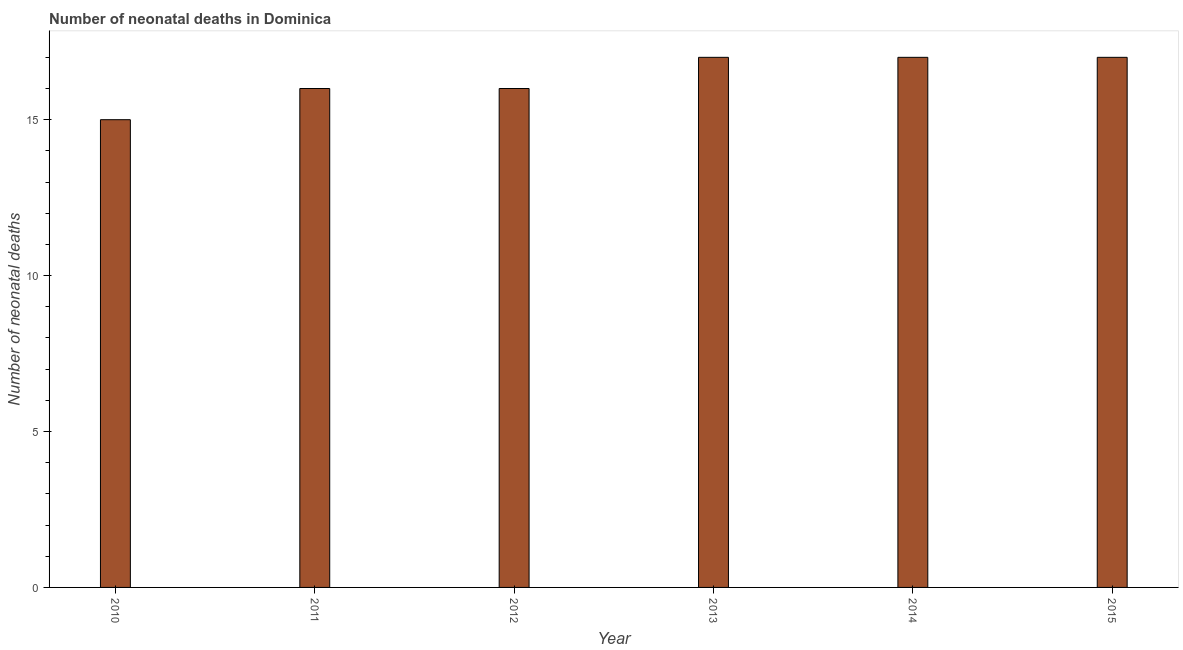Does the graph contain any zero values?
Provide a short and direct response. No. Does the graph contain grids?
Your response must be concise. No. What is the title of the graph?
Your answer should be compact. Number of neonatal deaths in Dominica. What is the label or title of the X-axis?
Your answer should be compact. Year. What is the label or title of the Y-axis?
Your answer should be compact. Number of neonatal deaths. What is the number of neonatal deaths in 2014?
Provide a succinct answer. 17. Across all years, what is the maximum number of neonatal deaths?
Your answer should be compact. 17. Across all years, what is the minimum number of neonatal deaths?
Ensure brevity in your answer.  15. In which year was the number of neonatal deaths maximum?
Your answer should be very brief. 2013. In which year was the number of neonatal deaths minimum?
Offer a very short reply. 2010. What is the difference between the number of neonatal deaths in 2014 and 2015?
Give a very brief answer. 0. What is the average number of neonatal deaths per year?
Your response must be concise. 16. In how many years, is the number of neonatal deaths greater than 2 ?
Your response must be concise. 6. Do a majority of the years between 2015 and 2013 (inclusive) have number of neonatal deaths greater than 13 ?
Your answer should be very brief. Yes. What is the ratio of the number of neonatal deaths in 2011 to that in 2013?
Keep it short and to the point. 0.94. What is the difference between the highest and the second highest number of neonatal deaths?
Your answer should be very brief. 0. Is the sum of the number of neonatal deaths in 2010 and 2011 greater than the maximum number of neonatal deaths across all years?
Your answer should be very brief. Yes. How many years are there in the graph?
Offer a very short reply. 6. Are the values on the major ticks of Y-axis written in scientific E-notation?
Your response must be concise. No. What is the Number of neonatal deaths in 2010?
Keep it short and to the point. 15. What is the Number of neonatal deaths of 2011?
Your response must be concise. 16. What is the Number of neonatal deaths of 2013?
Offer a very short reply. 17. What is the Number of neonatal deaths of 2014?
Offer a very short reply. 17. What is the difference between the Number of neonatal deaths in 2010 and 2011?
Offer a terse response. -1. What is the difference between the Number of neonatal deaths in 2010 and 2013?
Offer a very short reply. -2. What is the difference between the Number of neonatal deaths in 2010 and 2015?
Make the answer very short. -2. What is the difference between the Number of neonatal deaths in 2011 and 2015?
Make the answer very short. -1. What is the difference between the Number of neonatal deaths in 2012 and 2014?
Provide a short and direct response. -1. What is the difference between the Number of neonatal deaths in 2013 and 2014?
Provide a short and direct response. 0. What is the difference between the Number of neonatal deaths in 2013 and 2015?
Keep it short and to the point. 0. What is the difference between the Number of neonatal deaths in 2014 and 2015?
Offer a very short reply. 0. What is the ratio of the Number of neonatal deaths in 2010 to that in 2011?
Keep it short and to the point. 0.94. What is the ratio of the Number of neonatal deaths in 2010 to that in 2012?
Your answer should be compact. 0.94. What is the ratio of the Number of neonatal deaths in 2010 to that in 2013?
Provide a short and direct response. 0.88. What is the ratio of the Number of neonatal deaths in 2010 to that in 2014?
Your answer should be compact. 0.88. What is the ratio of the Number of neonatal deaths in 2010 to that in 2015?
Offer a very short reply. 0.88. What is the ratio of the Number of neonatal deaths in 2011 to that in 2013?
Give a very brief answer. 0.94. What is the ratio of the Number of neonatal deaths in 2011 to that in 2014?
Make the answer very short. 0.94. What is the ratio of the Number of neonatal deaths in 2011 to that in 2015?
Provide a short and direct response. 0.94. What is the ratio of the Number of neonatal deaths in 2012 to that in 2013?
Your response must be concise. 0.94. What is the ratio of the Number of neonatal deaths in 2012 to that in 2014?
Provide a succinct answer. 0.94. What is the ratio of the Number of neonatal deaths in 2012 to that in 2015?
Give a very brief answer. 0.94. What is the ratio of the Number of neonatal deaths in 2013 to that in 2014?
Your answer should be very brief. 1. What is the ratio of the Number of neonatal deaths in 2013 to that in 2015?
Ensure brevity in your answer.  1. What is the ratio of the Number of neonatal deaths in 2014 to that in 2015?
Keep it short and to the point. 1. 